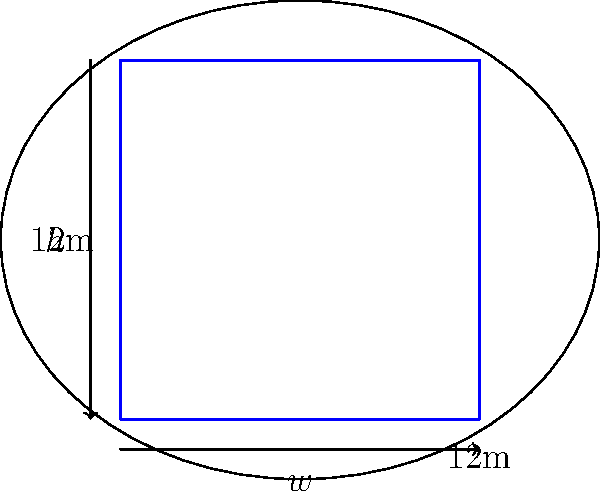As a ground handler working to improve luggage handling efficiency, you're tasked with determining the optimal shape and dimensions for a luggage container to maximize storage capacity on an aircraft. Given that the aircraft's cargo hold has an elliptical cross-section with a width of 12 meters and a height of 8 meters, what shape and dimensions would you recommend for the luggage container to maximize its volume while fitting within the cargo hold? To maximize the storage capacity of the luggage container within the elliptical cross-section of the aircraft's cargo hold, we need to find the largest rectangular shape that fits inside the ellipse. This problem is known as the "largest rectangle in an ellipse" problem.

Step 1: The equation of the ellipse is given by:
$$ \frac{x^2}{a^2} + \frac{y^2}{b^2} = 1 $$
where $a = 6$ (half-width) and $b = 4$ (half-height).

Step 2: For a rectangle with width $w$ and height $h$ inscribed in this ellipse, we want to maximize the area:
$$ A = wh $$

Step 3: The optimal ratio of width to height for the largest rectangle in an ellipse is given by:
$$ \frac{w}{h} = \sqrt{\frac{a}{b}} = \sqrt{\frac{6}{4}} = \sqrt{\frac{3}{2}} \approx 1.225 $$

Step 4: Using this ratio and the ellipse equation, we can derive the optimal dimensions:
$$ w = 2a\sqrt{\frac{2}{3}} \approx 9.798 \text{ meters} $$
$$ h = 2b\sqrt{\frac{2}{3}} \approx 8 \text{ meters} $$

Step 5: The maximum volume of the container would be:
$$ V = w * h * l $$
where $l$ is the length of the container, which depends on the aircraft's cargo hold length.

Therefore, the optimal shape for the luggage container is a rectangular prism with a square cross-section (when viewed from the front or back of the aircraft), with dimensions of approximately 9.8 meters in width and 8 meters in height.
Answer: Rectangular prism: 9.8m width, 8m height, length based on cargo hold 